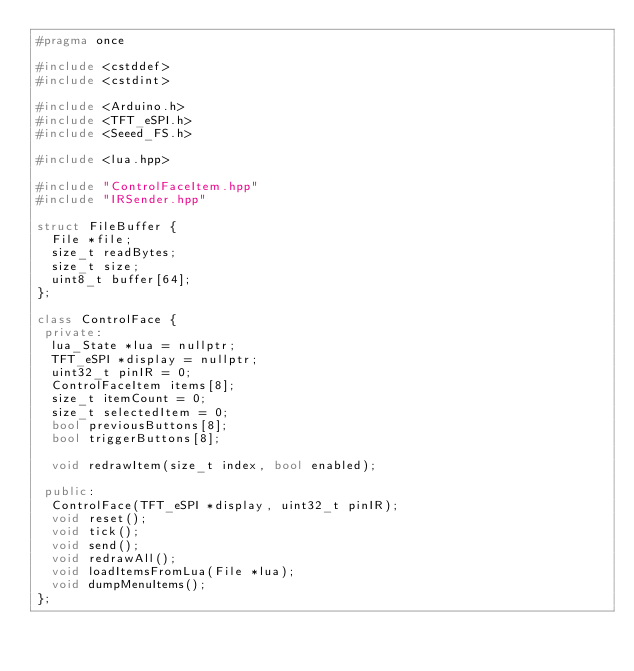Convert code to text. <code><loc_0><loc_0><loc_500><loc_500><_C++_>#pragma once

#include <cstddef>
#include <cstdint>

#include <Arduino.h>
#include <TFT_eSPI.h>
#include <Seeed_FS.h>

#include <lua.hpp>

#include "ControlFaceItem.hpp"
#include "IRSender.hpp"

struct FileBuffer {
  File *file;
  size_t readBytes;
  size_t size;
  uint8_t buffer[64];
};

class ControlFace {
 private:
  lua_State *lua = nullptr;
  TFT_eSPI *display = nullptr;
  uint32_t pinIR = 0;
  ControlFaceItem items[8];
  size_t itemCount = 0;
  size_t selectedItem = 0;
  bool previousButtons[8];
  bool triggerButtons[8];

  void redrawItem(size_t index, bool enabled);

 public:
  ControlFace(TFT_eSPI *display, uint32_t pinIR);
  void reset();
  void tick();
  void send();
  void redrawAll();
  void loadItemsFromLua(File *lua);
  void dumpMenuItems();
};
</code> 